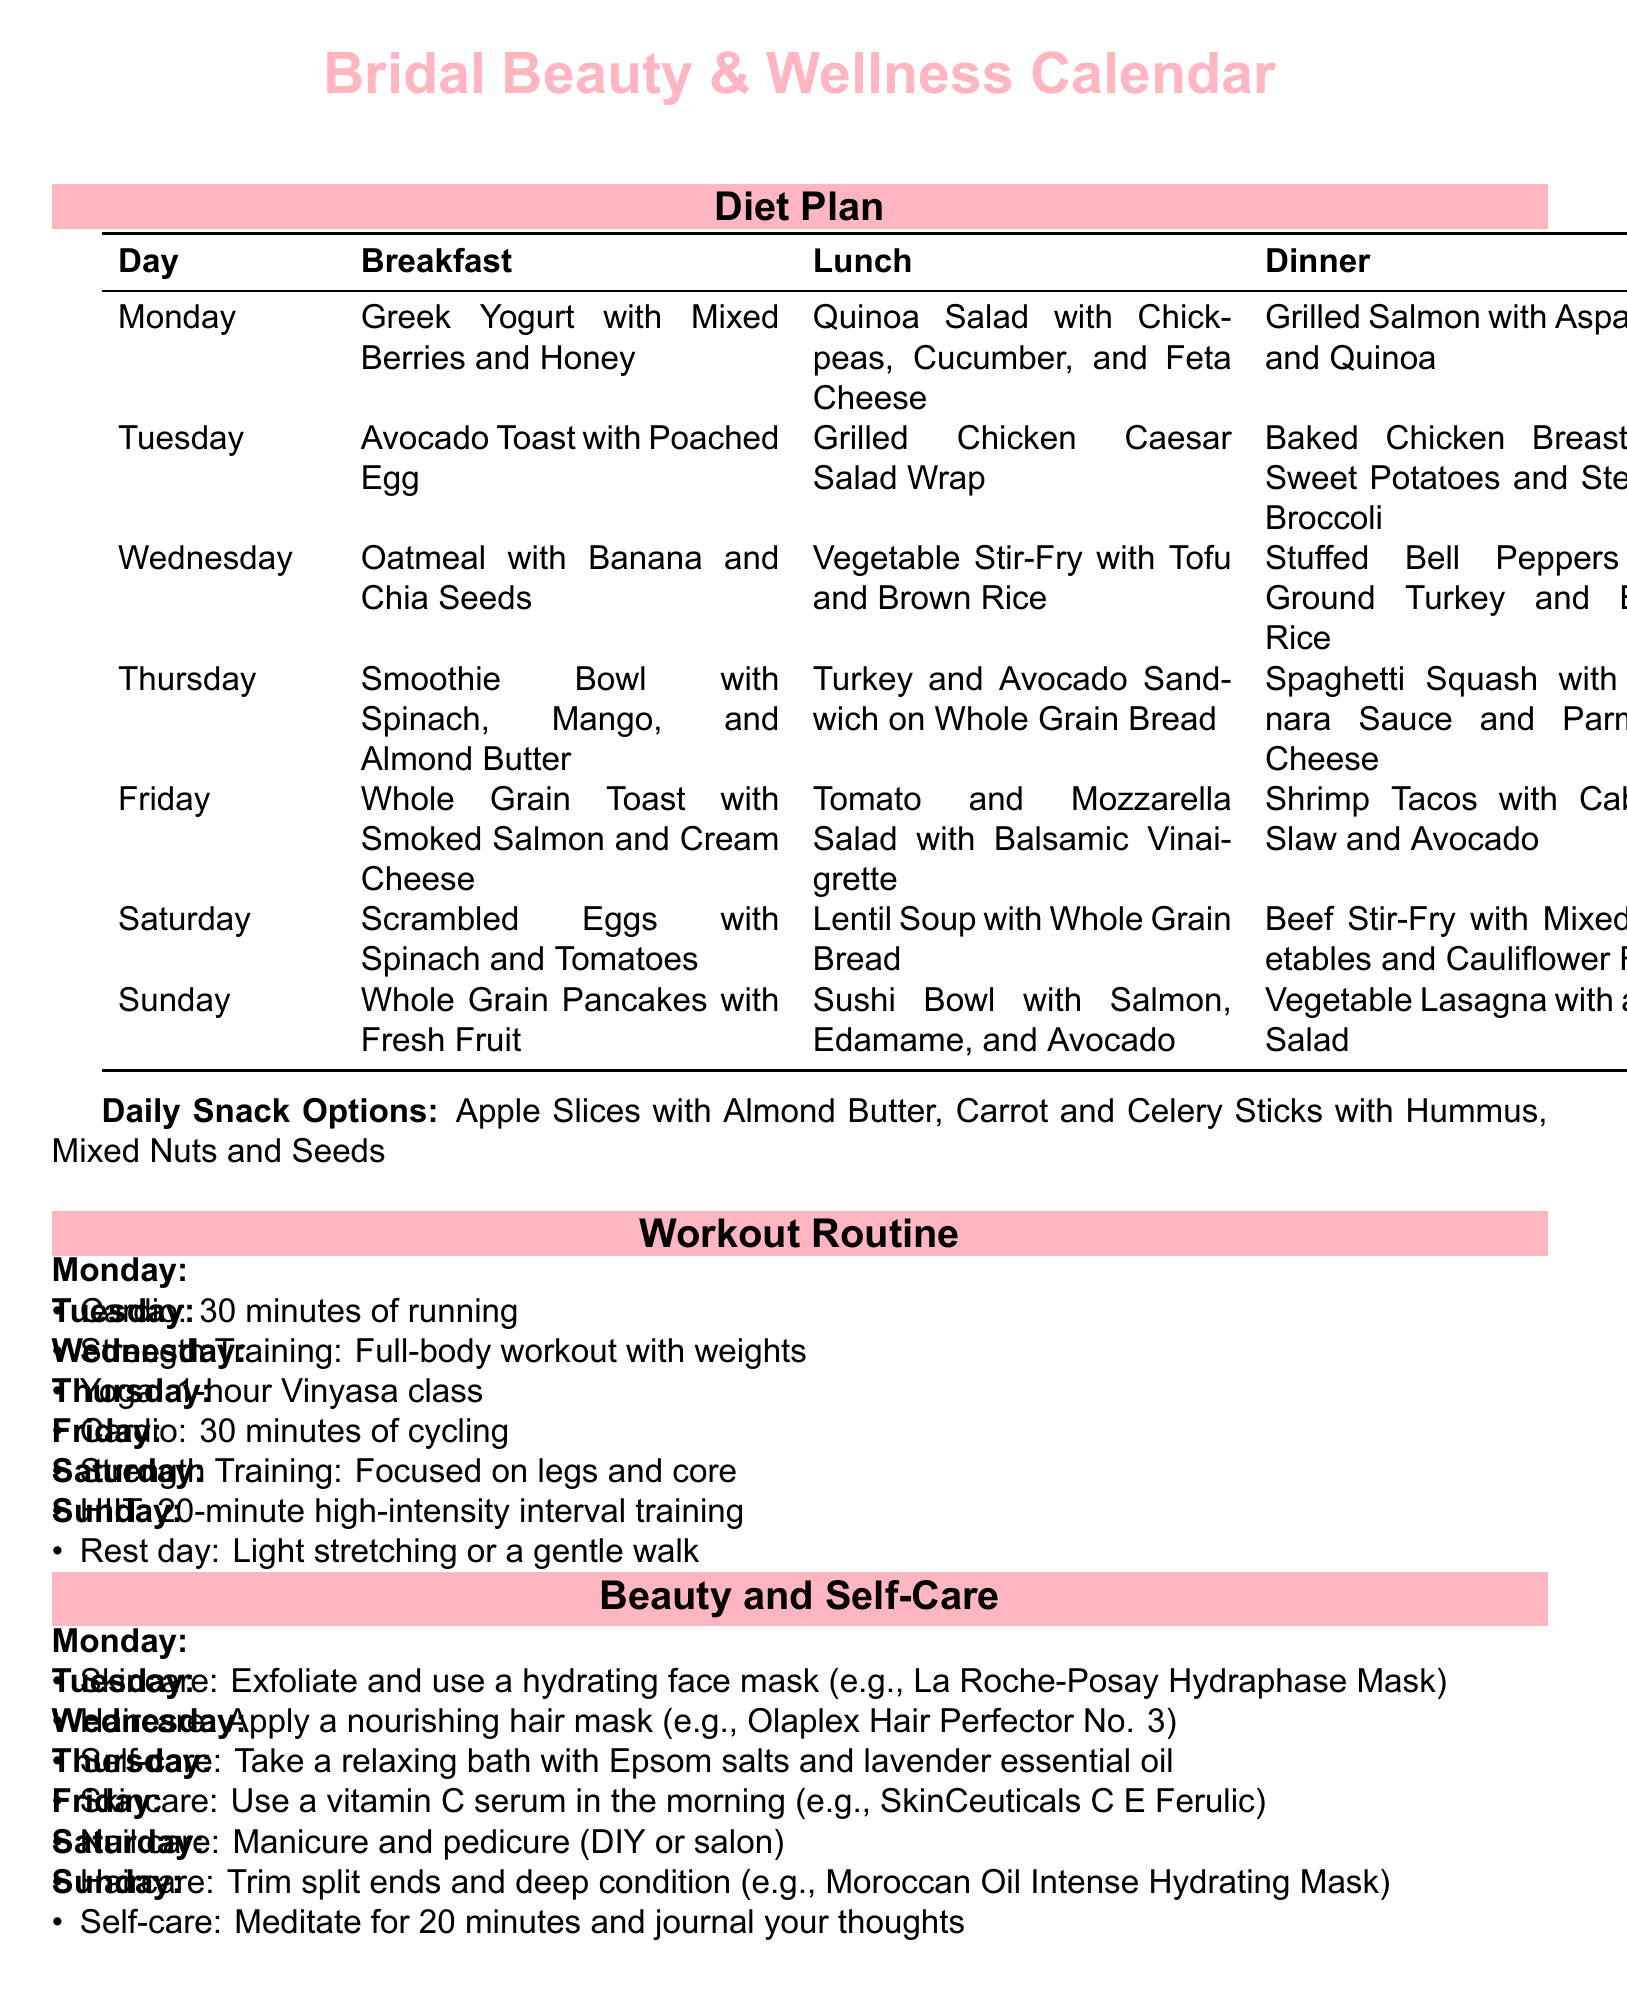What is the breakfast on Tuesday? The breakfast listed for Tuesday in the diet plan is "Avocado Toast with Poached Egg."
Answer: Avocado Toast with Poached Egg How many days of cardio workouts are scheduled? There are cardio workouts scheduled for Monday, Thursday, and one HIIT session, which includes cardio, so the total is three.
Answer: 3 What is the dinner on Friday? The dinner on Friday is "Shrimp Tacos with Cabbage Slaw and Avocado."
Answer: Shrimp Tacos with Cabbage Slaw and Avocado What type of self-care is suggested for Wednesday? The self-care suggested for Wednesday is to "Take a relaxing bath with Epsom salts and lavender essential oil."
Answer: Take a relaxing bath with Epsom salts and lavender essential oil What is the target workout for Friday? The target workout for Friday is "Strength Training: Focused on legs and core."
Answer: Strength Training: Focused on legs and core Which haircare product is mentioned for Tuesday? The haircare product mentioned for Tuesday is "Olaplex Hair Perfector No. 3."
Answer: Olaplex Hair Perfector No. 3 What activity is scheduled for Sunday? Sunday is designated as a "Rest day: Light stretching or a gentle walk."
Answer: Rest day: Light stretching or a gentle walk How long is the meditation session suggested for Sunday? The meditation session suggested for Sunday is for "20 minutes."
Answer: 20 minutes 